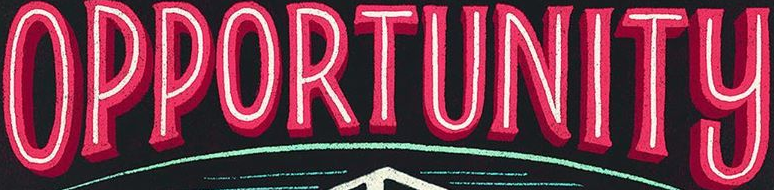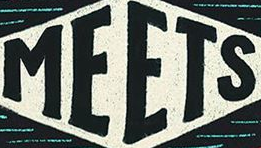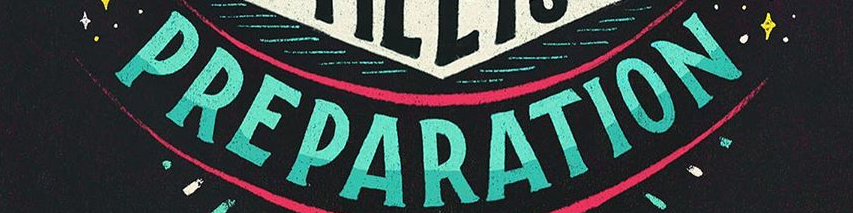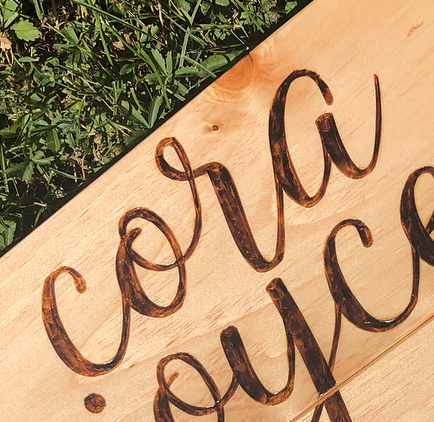What text is displayed in these images sequentially, separated by a semicolon? OPPORTUNITY; MEETS; PREPARATION; cora 